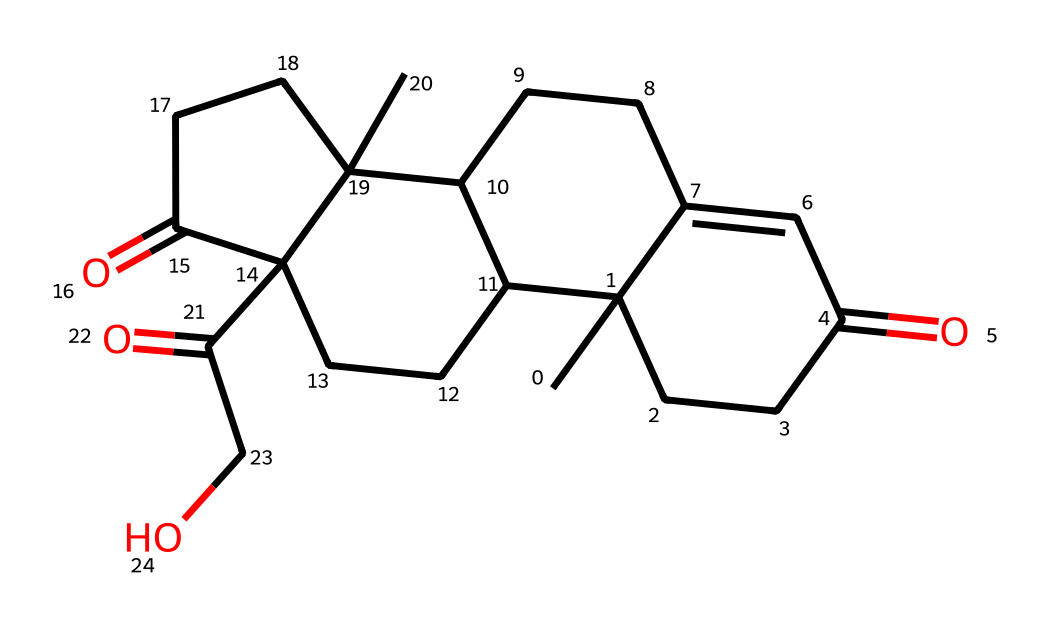What is the molecular formula of cortisol? To determine the molecular formula, count the number of carbon (C), hydrogen (H), and oxygen (O) atoms present in the SMILES representation. The structure indicates 21 carbon atoms, 30 hydrogen atoms, and 5 oxygen atoms. This gives the molecular formula as C21H30O5.
Answer: C21H30O5 How many rings are present in this chemical structure? By examining the SMILES representation, we can identify the presence of cyclic structures. The numbers in the SMILES denote the start and end of rings, and here we can find four distinct ring closures. Thus, there are four rings in the structure.
Answer: 4 What type of hormone is cortisol classified as? Cortisol is primarily classified as a glucocorticoid hormone, which is a type of steroid hormone. Its structure, showcasing multiple interconnected rings and functional groups, supports its classification in this family of hormones.
Answer: glucocorticoid Does cortisol have any functional groups? Yes, cortisol contains ketone and hydroxyl functional groups. The multiple carbonyl (C=O) groups (identified in the structure) and the -OH groups indicate these functional groups, which contribute to its biological activity.
Answer: yes How many total oxygen atoms does cortisol contain? By analyzing the chemcial structure again, we count the oxygen atoms present in the molecular structure. The SMILES representation clearly indicates there are five oxygen atoms in cortisol.
Answer: 5 What is the significance of cortisol in stress response? Cortisol plays a crucial role in the body's response to stress by regulating various functions such as metabolism, immune response, and inflammation. Its chemical structure allows it to bind effectively to receptors, influencing numerous physiological processes during stress.
Answer: stress hormone 